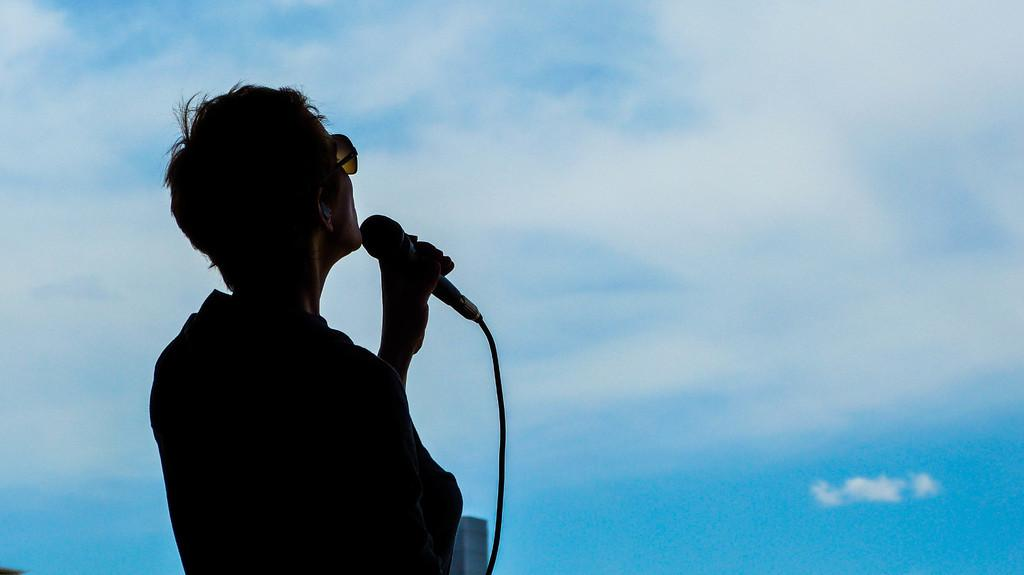Who or what is the main subject in the image? There is a person in the image. What is the person holding in the image? The person is holding a microphone. Can you describe any accessories the person is wearing? The person is wearing glasses. What can be seen in the background of the image? The sky is visible in the image. What type of cup is the person holding in the image? There is no cup present in the image; the person is holding a microphone. What event is the person attending in the image? There is no information about an event in the image; it only shows a person holding a microphone and wearing glasses with the sky visible in the background. 